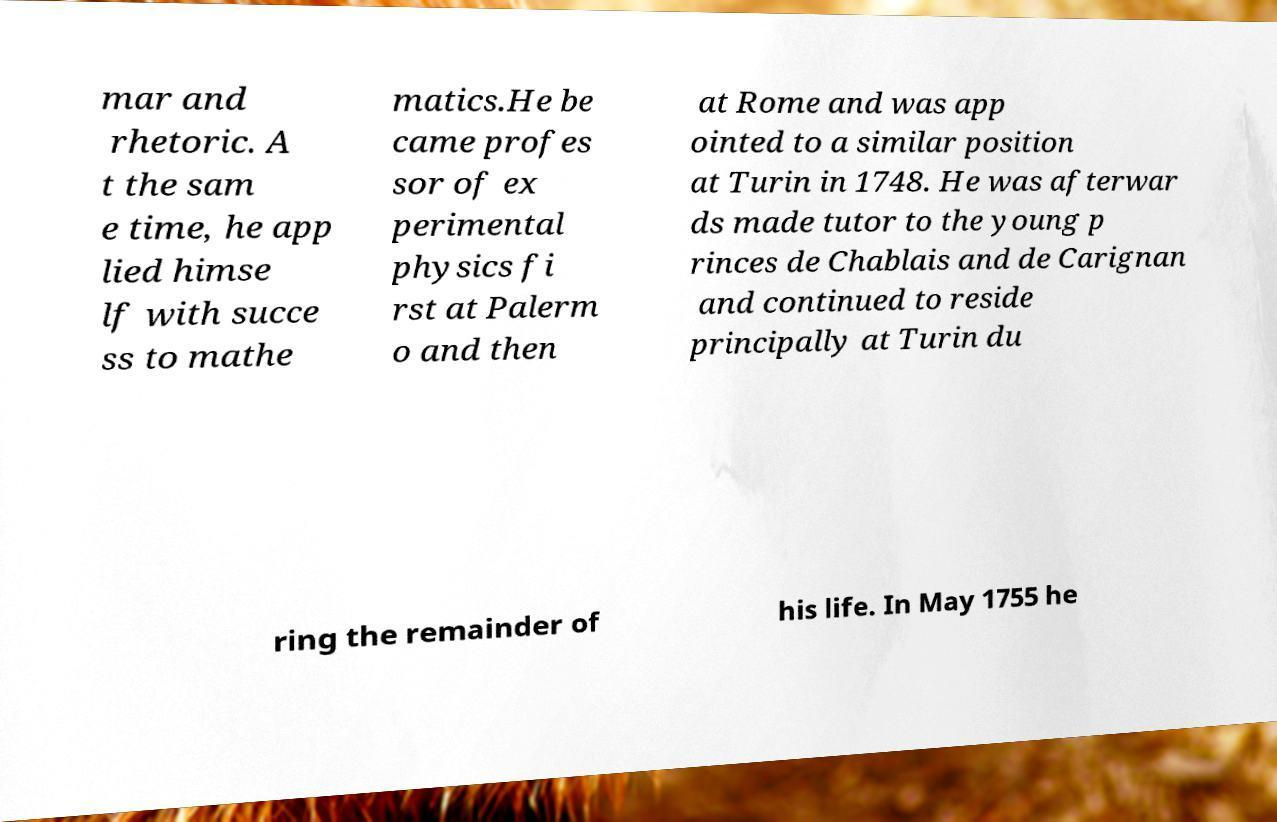Please read and relay the text visible in this image. What does it say? mar and rhetoric. A t the sam e time, he app lied himse lf with succe ss to mathe matics.He be came profes sor of ex perimental physics fi rst at Palerm o and then at Rome and was app ointed to a similar position at Turin in 1748. He was afterwar ds made tutor to the young p rinces de Chablais and de Carignan and continued to reside principally at Turin du ring the remainder of his life. In May 1755 he 